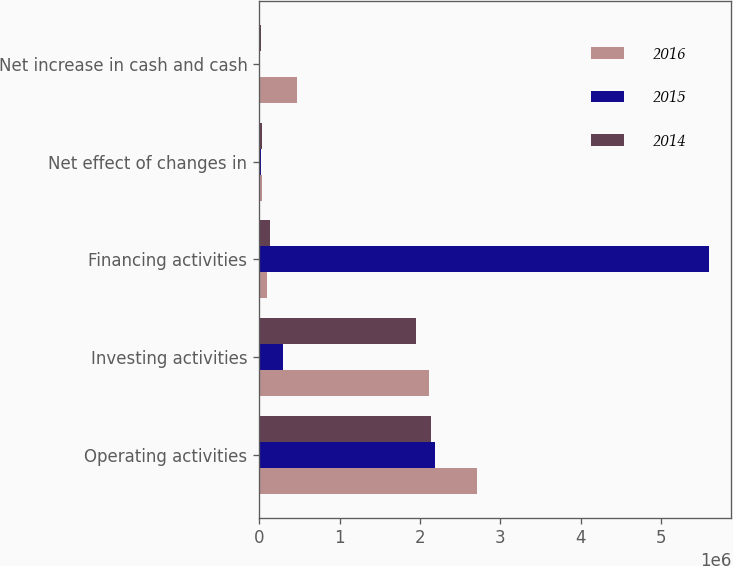Convert chart. <chart><loc_0><loc_0><loc_500><loc_500><stacked_bar_chart><ecel><fcel>Operating activities<fcel>Investing activities<fcel>Financing activities<fcel>Net effect of changes in<fcel>Net increase in cash and cash<nl><fcel>2016<fcel>2.7036e+06<fcel>2.10745e+06<fcel>99294<fcel>30389<fcel>466475<nl><fcel>2015<fcel>2.18305e+06<fcel>300533<fcel>5.5891e+06<fcel>23224<fcel>7194<nl><fcel>2014<fcel>2.13459e+06<fcel>1.94955e+06<fcel>134591<fcel>30534<fcel>19916<nl></chart> 